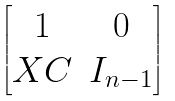Convert formula to latex. <formula><loc_0><loc_0><loc_500><loc_500>\begin{bmatrix} 1 & 0 \\ X C & I _ { n - 1 } \end{bmatrix}</formula> 